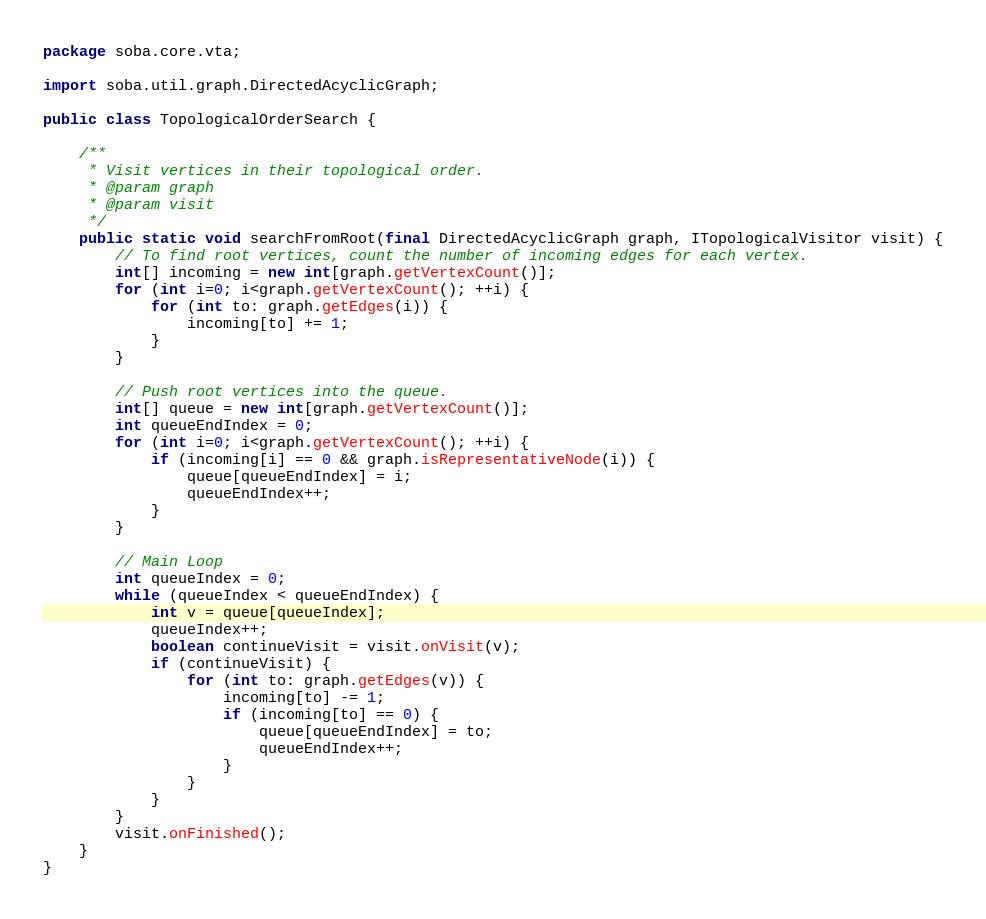Convert code to text. <code><loc_0><loc_0><loc_500><loc_500><_Java_>package soba.core.vta;

import soba.util.graph.DirectedAcyclicGraph;

public class TopologicalOrderSearch {

	/**
	 * Visit vertices in their topological order.
	 * @param graph
	 * @param visit
	 */
	public static void searchFromRoot(final DirectedAcyclicGraph graph, ITopologicalVisitor visit) {
		// To find root vertices, count the number of incoming edges for each vertex.
		int[] incoming = new int[graph.getVertexCount()];
		for (int i=0; i<graph.getVertexCount(); ++i) {
			for (int to: graph.getEdges(i)) {
				incoming[to] += 1;
			}
		}
		
		// Push root vertices into the queue.
		int[] queue = new int[graph.getVertexCount()];
		int queueEndIndex = 0;
		for (int i=0; i<graph.getVertexCount(); ++i) {
			if (incoming[i] == 0 && graph.isRepresentativeNode(i)) {
				queue[queueEndIndex] = i;
				queueEndIndex++;
			}
		}
		
		// Main Loop
		int queueIndex = 0;
		while (queueIndex < queueEndIndex) {
			int v = queue[queueIndex];
			queueIndex++;
			boolean continueVisit = visit.onVisit(v);
			if (continueVisit) {
				for (int to: graph.getEdges(v)) {
					incoming[to] -= 1;
					if (incoming[to] == 0) {
						queue[queueEndIndex] = to;
						queueEndIndex++;
					}
				}
			}
		}
		visit.onFinished();
	}
}
</code> 